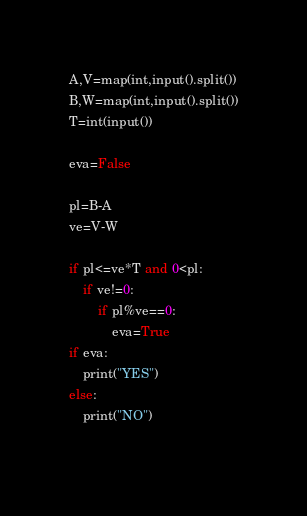<code> <loc_0><loc_0><loc_500><loc_500><_Python_>A,V=map(int,input().split())
B,W=map(int,input().split())
T=int(input())

eva=False

pl=B-A
ve=V-W

if pl<=ve*T and 0<pl:
    if ve!=0:
        if pl%ve==0:
            eva=True
if eva:
    print("YES")
else:
    print("NO")
    </code> 